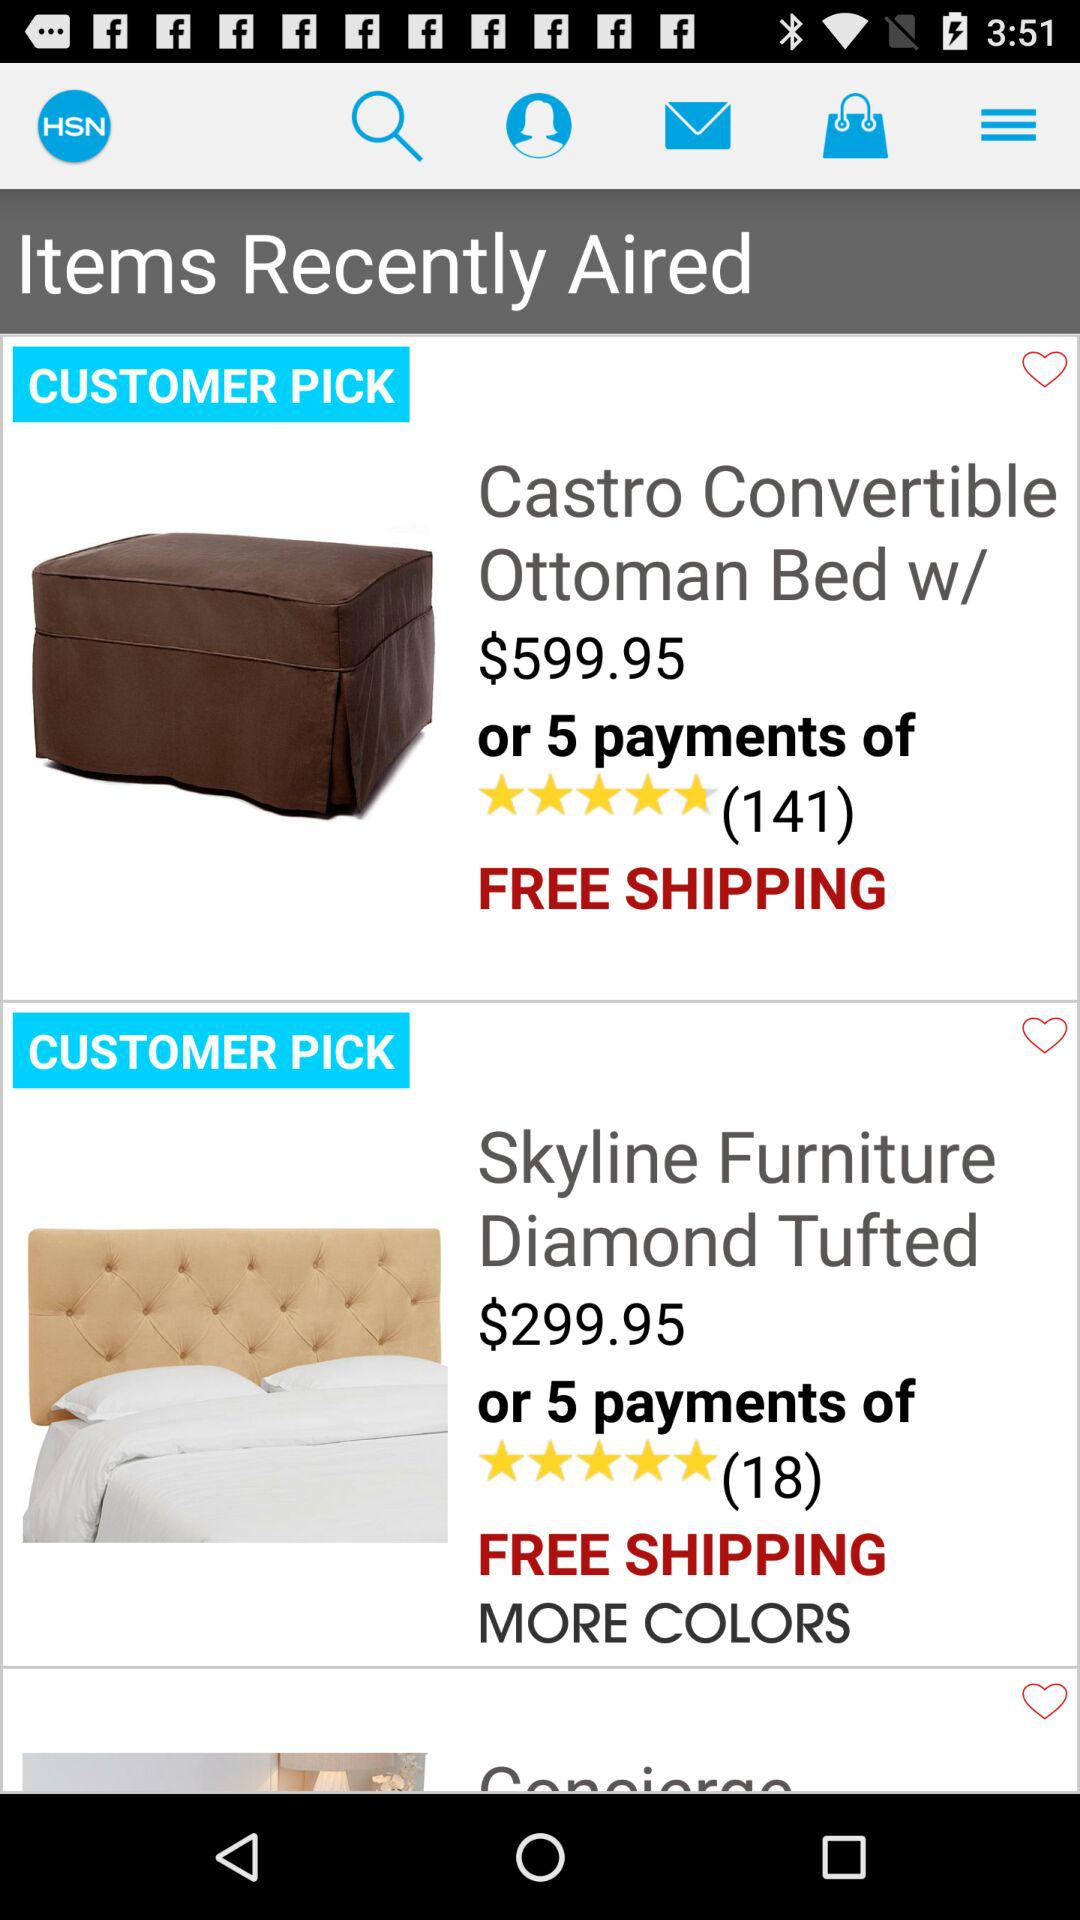What is the price of the "Castro Convertible Ottoman Bed"? The price of the "Castro Convertible Ottoman Bed" is $599.95. 